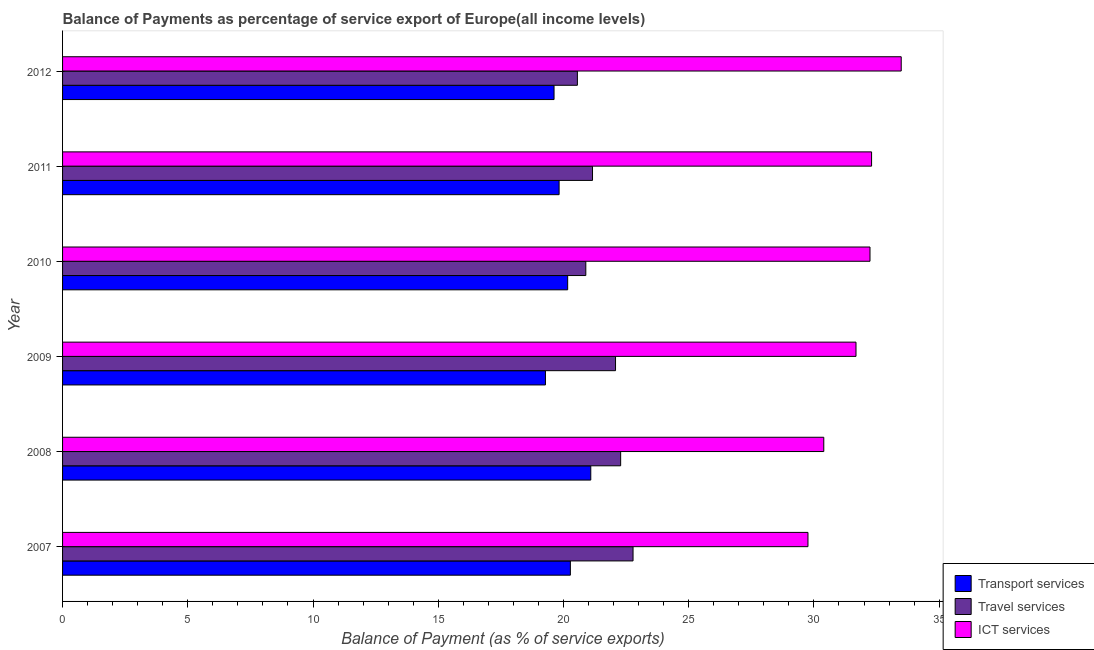How many groups of bars are there?
Your answer should be compact. 6. Are the number of bars per tick equal to the number of legend labels?
Provide a succinct answer. Yes. How many bars are there on the 4th tick from the bottom?
Offer a very short reply. 3. In how many cases, is the number of bars for a given year not equal to the number of legend labels?
Provide a succinct answer. 0. What is the balance of payment of ict services in 2007?
Keep it short and to the point. 29.76. Across all years, what is the maximum balance of payment of travel services?
Make the answer very short. 22.78. Across all years, what is the minimum balance of payment of transport services?
Offer a terse response. 19.28. In which year was the balance of payment of ict services minimum?
Your answer should be very brief. 2007. What is the total balance of payment of transport services in the graph?
Ensure brevity in your answer.  120.27. What is the difference between the balance of payment of transport services in 2008 and that in 2012?
Your answer should be very brief. 1.47. What is the difference between the balance of payment of travel services in 2009 and the balance of payment of ict services in 2008?
Your answer should be compact. -8.31. What is the average balance of payment of ict services per year?
Ensure brevity in your answer.  31.64. In the year 2012, what is the difference between the balance of payment of travel services and balance of payment of transport services?
Your answer should be very brief. 0.93. In how many years, is the balance of payment of ict services greater than 25 %?
Your answer should be very brief. 6. What is the ratio of the balance of payment of transport services in 2009 to that in 2012?
Your answer should be compact. 0.98. Is the balance of payment of travel services in 2008 less than that in 2011?
Make the answer very short. No. What is the difference between the highest and the second highest balance of payment of transport services?
Provide a short and direct response. 0.81. What is the difference between the highest and the lowest balance of payment of ict services?
Your answer should be compact. 3.72. In how many years, is the balance of payment of travel services greater than the average balance of payment of travel services taken over all years?
Ensure brevity in your answer.  3. What does the 2nd bar from the top in 2011 represents?
Keep it short and to the point. Travel services. What does the 1st bar from the bottom in 2007 represents?
Your response must be concise. Transport services. Is it the case that in every year, the sum of the balance of payment of transport services and balance of payment of travel services is greater than the balance of payment of ict services?
Provide a short and direct response. Yes. Are all the bars in the graph horizontal?
Keep it short and to the point. Yes. How many years are there in the graph?
Offer a very short reply. 6. What is the difference between two consecutive major ticks on the X-axis?
Give a very brief answer. 5. Are the values on the major ticks of X-axis written in scientific E-notation?
Keep it short and to the point. No. Does the graph contain grids?
Provide a succinct answer. No. Where does the legend appear in the graph?
Make the answer very short. Bottom right. How many legend labels are there?
Provide a short and direct response. 3. How are the legend labels stacked?
Your response must be concise. Vertical. What is the title of the graph?
Offer a very short reply. Balance of Payments as percentage of service export of Europe(all income levels). Does "Slovak Republic" appear as one of the legend labels in the graph?
Ensure brevity in your answer.  No. What is the label or title of the X-axis?
Offer a terse response. Balance of Payment (as % of service exports). What is the label or title of the Y-axis?
Ensure brevity in your answer.  Year. What is the Balance of Payment (as % of service exports) in Transport services in 2007?
Give a very brief answer. 20.28. What is the Balance of Payment (as % of service exports) of Travel services in 2007?
Offer a terse response. 22.78. What is the Balance of Payment (as % of service exports) of ICT services in 2007?
Make the answer very short. 29.76. What is the Balance of Payment (as % of service exports) of Transport services in 2008?
Your response must be concise. 21.09. What is the Balance of Payment (as % of service exports) of Travel services in 2008?
Offer a very short reply. 22.28. What is the Balance of Payment (as % of service exports) of ICT services in 2008?
Give a very brief answer. 30.39. What is the Balance of Payment (as % of service exports) in Transport services in 2009?
Provide a succinct answer. 19.28. What is the Balance of Payment (as % of service exports) of Travel services in 2009?
Keep it short and to the point. 22.08. What is the Balance of Payment (as % of service exports) of ICT services in 2009?
Offer a very short reply. 31.68. What is the Balance of Payment (as % of service exports) in Transport services in 2010?
Keep it short and to the point. 20.17. What is the Balance of Payment (as % of service exports) in Travel services in 2010?
Offer a very short reply. 20.89. What is the Balance of Payment (as % of service exports) of ICT services in 2010?
Offer a very short reply. 32.24. What is the Balance of Payment (as % of service exports) of Transport services in 2011?
Make the answer very short. 19.83. What is the Balance of Payment (as % of service exports) in Travel services in 2011?
Your response must be concise. 21.16. What is the Balance of Payment (as % of service exports) of ICT services in 2011?
Offer a very short reply. 32.3. What is the Balance of Payment (as % of service exports) of Transport services in 2012?
Your answer should be very brief. 19.62. What is the Balance of Payment (as % of service exports) in Travel services in 2012?
Make the answer very short. 20.56. What is the Balance of Payment (as % of service exports) of ICT services in 2012?
Offer a terse response. 33.49. Across all years, what is the maximum Balance of Payment (as % of service exports) in Transport services?
Your answer should be very brief. 21.09. Across all years, what is the maximum Balance of Payment (as % of service exports) of Travel services?
Offer a very short reply. 22.78. Across all years, what is the maximum Balance of Payment (as % of service exports) in ICT services?
Provide a succinct answer. 33.49. Across all years, what is the minimum Balance of Payment (as % of service exports) of Transport services?
Make the answer very short. 19.28. Across all years, what is the minimum Balance of Payment (as % of service exports) of Travel services?
Keep it short and to the point. 20.56. Across all years, what is the minimum Balance of Payment (as % of service exports) of ICT services?
Give a very brief answer. 29.76. What is the total Balance of Payment (as % of service exports) of Transport services in the graph?
Your answer should be compact. 120.27. What is the total Balance of Payment (as % of service exports) of Travel services in the graph?
Provide a short and direct response. 129.75. What is the total Balance of Payment (as % of service exports) of ICT services in the graph?
Give a very brief answer. 189.86. What is the difference between the Balance of Payment (as % of service exports) in Transport services in 2007 and that in 2008?
Your response must be concise. -0.82. What is the difference between the Balance of Payment (as % of service exports) of Travel services in 2007 and that in 2008?
Provide a succinct answer. 0.49. What is the difference between the Balance of Payment (as % of service exports) of ICT services in 2007 and that in 2008?
Offer a very short reply. -0.63. What is the difference between the Balance of Payment (as % of service exports) in Transport services in 2007 and that in 2009?
Give a very brief answer. 0.99. What is the difference between the Balance of Payment (as % of service exports) of Travel services in 2007 and that in 2009?
Your answer should be compact. 0.7. What is the difference between the Balance of Payment (as % of service exports) of ICT services in 2007 and that in 2009?
Your answer should be very brief. -1.92. What is the difference between the Balance of Payment (as % of service exports) in Transport services in 2007 and that in 2010?
Your answer should be very brief. 0.11. What is the difference between the Balance of Payment (as % of service exports) in Travel services in 2007 and that in 2010?
Ensure brevity in your answer.  1.89. What is the difference between the Balance of Payment (as % of service exports) in ICT services in 2007 and that in 2010?
Ensure brevity in your answer.  -2.48. What is the difference between the Balance of Payment (as % of service exports) in Transport services in 2007 and that in 2011?
Offer a terse response. 0.45. What is the difference between the Balance of Payment (as % of service exports) in Travel services in 2007 and that in 2011?
Provide a short and direct response. 1.62. What is the difference between the Balance of Payment (as % of service exports) in ICT services in 2007 and that in 2011?
Offer a very short reply. -2.54. What is the difference between the Balance of Payment (as % of service exports) of Transport services in 2007 and that in 2012?
Offer a very short reply. 0.65. What is the difference between the Balance of Payment (as % of service exports) of Travel services in 2007 and that in 2012?
Your response must be concise. 2.22. What is the difference between the Balance of Payment (as % of service exports) of ICT services in 2007 and that in 2012?
Provide a short and direct response. -3.72. What is the difference between the Balance of Payment (as % of service exports) in Transport services in 2008 and that in 2009?
Give a very brief answer. 1.81. What is the difference between the Balance of Payment (as % of service exports) of Travel services in 2008 and that in 2009?
Offer a very short reply. 0.2. What is the difference between the Balance of Payment (as % of service exports) in ICT services in 2008 and that in 2009?
Your answer should be very brief. -1.29. What is the difference between the Balance of Payment (as % of service exports) in Travel services in 2008 and that in 2010?
Make the answer very short. 1.39. What is the difference between the Balance of Payment (as % of service exports) of ICT services in 2008 and that in 2010?
Your answer should be very brief. -1.85. What is the difference between the Balance of Payment (as % of service exports) in Transport services in 2008 and that in 2011?
Offer a very short reply. 1.26. What is the difference between the Balance of Payment (as % of service exports) of Travel services in 2008 and that in 2011?
Give a very brief answer. 1.12. What is the difference between the Balance of Payment (as % of service exports) of ICT services in 2008 and that in 2011?
Your answer should be compact. -1.91. What is the difference between the Balance of Payment (as % of service exports) of Transport services in 2008 and that in 2012?
Give a very brief answer. 1.47. What is the difference between the Balance of Payment (as % of service exports) of Travel services in 2008 and that in 2012?
Give a very brief answer. 1.73. What is the difference between the Balance of Payment (as % of service exports) of ICT services in 2008 and that in 2012?
Your response must be concise. -3.09. What is the difference between the Balance of Payment (as % of service exports) of Transport services in 2009 and that in 2010?
Make the answer very short. -0.89. What is the difference between the Balance of Payment (as % of service exports) in Travel services in 2009 and that in 2010?
Provide a succinct answer. 1.19. What is the difference between the Balance of Payment (as % of service exports) in ICT services in 2009 and that in 2010?
Provide a short and direct response. -0.56. What is the difference between the Balance of Payment (as % of service exports) in Transport services in 2009 and that in 2011?
Offer a very short reply. -0.55. What is the difference between the Balance of Payment (as % of service exports) in Travel services in 2009 and that in 2011?
Give a very brief answer. 0.92. What is the difference between the Balance of Payment (as % of service exports) of ICT services in 2009 and that in 2011?
Keep it short and to the point. -0.62. What is the difference between the Balance of Payment (as % of service exports) of Transport services in 2009 and that in 2012?
Provide a succinct answer. -0.34. What is the difference between the Balance of Payment (as % of service exports) of Travel services in 2009 and that in 2012?
Ensure brevity in your answer.  1.52. What is the difference between the Balance of Payment (as % of service exports) of ICT services in 2009 and that in 2012?
Keep it short and to the point. -1.81. What is the difference between the Balance of Payment (as % of service exports) in Transport services in 2010 and that in 2011?
Ensure brevity in your answer.  0.34. What is the difference between the Balance of Payment (as % of service exports) in Travel services in 2010 and that in 2011?
Your answer should be compact. -0.27. What is the difference between the Balance of Payment (as % of service exports) in ICT services in 2010 and that in 2011?
Give a very brief answer. -0.06. What is the difference between the Balance of Payment (as % of service exports) in Transport services in 2010 and that in 2012?
Provide a short and direct response. 0.54. What is the difference between the Balance of Payment (as % of service exports) of Travel services in 2010 and that in 2012?
Offer a very short reply. 0.34. What is the difference between the Balance of Payment (as % of service exports) of ICT services in 2010 and that in 2012?
Offer a terse response. -1.25. What is the difference between the Balance of Payment (as % of service exports) in Transport services in 2011 and that in 2012?
Make the answer very short. 0.2. What is the difference between the Balance of Payment (as % of service exports) in Travel services in 2011 and that in 2012?
Your response must be concise. 0.6. What is the difference between the Balance of Payment (as % of service exports) in ICT services in 2011 and that in 2012?
Keep it short and to the point. -1.18. What is the difference between the Balance of Payment (as % of service exports) of Transport services in 2007 and the Balance of Payment (as % of service exports) of Travel services in 2008?
Your answer should be very brief. -2.01. What is the difference between the Balance of Payment (as % of service exports) of Transport services in 2007 and the Balance of Payment (as % of service exports) of ICT services in 2008?
Ensure brevity in your answer.  -10.12. What is the difference between the Balance of Payment (as % of service exports) of Travel services in 2007 and the Balance of Payment (as % of service exports) of ICT services in 2008?
Your response must be concise. -7.62. What is the difference between the Balance of Payment (as % of service exports) of Transport services in 2007 and the Balance of Payment (as % of service exports) of Travel services in 2009?
Your answer should be very brief. -1.8. What is the difference between the Balance of Payment (as % of service exports) in Transport services in 2007 and the Balance of Payment (as % of service exports) in ICT services in 2009?
Offer a very short reply. -11.4. What is the difference between the Balance of Payment (as % of service exports) in Travel services in 2007 and the Balance of Payment (as % of service exports) in ICT services in 2009?
Your response must be concise. -8.9. What is the difference between the Balance of Payment (as % of service exports) in Transport services in 2007 and the Balance of Payment (as % of service exports) in Travel services in 2010?
Give a very brief answer. -0.62. What is the difference between the Balance of Payment (as % of service exports) in Transport services in 2007 and the Balance of Payment (as % of service exports) in ICT services in 2010?
Your response must be concise. -11.96. What is the difference between the Balance of Payment (as % of service exports) in Travel services in 2007 and the Balance of Payment (as % of service exports) in ICT services in 2010?
Your answer should be compact. -9.46. What is the difference between the Balance of Payment (as % of service exports) of Transport services in 2007 and the Balance of Payment (as % of service exports) of Travel services in 2011?
Provide a succinct answer. -0.88. What is the difference between the Balance of Payment (as % of service exports) in Transport services in 2007 and the Balance of Payment (as % of service exports) in ICT services in 2011?
Your answer should be compact. -12.03. What is the difference between the Balance of Payment (as % of service exports) of Travel services in 2007 and the Balance of Payment (as % of service exports) of ICT services in 2011?
Offer a very short reply. -9.52. What is the difference between the Balance of Payment (as % of service exports) of Transport services in 2007 and the Balance of Payment (as % of service exports) of Travel services in 2012?
Your response must be concise. -0.28. What is the difference between the Balance of Payment (as % of service exports) of Transport services in 2007 and the Balance of Payment (as % of service exports) of ICT services in 2012?
Ensure brevity in your answer.  -13.21. What is the difference between the Balance of Payment (as % of service exports) of Travel services in 2007 and the Balance of Payment (as % of service exports) of ICT services in 2012?
Your response must be concise. -10.71. What is the difference between the Balance of Payment (as % of service exports) of Transport services in 2008 and the Balance of Payment (as % of service exports) of Travel services in 2009?
Ensure brevity in your answer.  -0.99. What is the difference between the Balance of Payment (as % of service exports) of Transport services in 2008 and the Balance of Payment (as % of service exports) of ICT services in 2009?
Your answer should be compact. -10.59. What is the difference between the Balance of Payment (as % of service exports) of Travel services in 2008 and the Balance of Payment (as % of service exports) of ICT services in 2009?
Your answer should be compact. -9.4. What is the difference between the Balance of Payment (as % of service exports) in Transport services in 2008 and the Balance of Payment (as % of service exports) in Travel services in 2010?
Your response must be concise. 0.2. What is the difference between the Balance of Payment (as % of service exports) in Transport services in 2008 and the Balance of Payment (as % of service exports) in ICT services in 2010?
Your response must be concise. -11.15. What is the difference between the Balance of Payment (as % of service exports) of Travel services in 2008 and the Balance of Payment (as % of service exports) of ICT services in 2010?
Ensure brevity in your answer.  -9.96. What is the difference between the Balance of Payment (as % of service exports) of Transport services in 2008 and the Balance of Payment (as % of service exports) of Travel services in 2011?
Provide a succinct answer. -0.07. What is the difference between the Balance of Payment (as % of service exports) in Transport services in 2008 and the Balance of Payment (as % of service exports) in ICT services in 2011?
Keep it short and to the point. -11.21. What is the difference between the Balance of Payment (as % of service exports) in Travel services in 2008 and the Balance of Payment (as % of service exports) in ICT services in 2011?
Offer a terse response. -10.02. What is the difference between the Balance of Payment (as % of service exports) in Transport services in 2008 and the Balance of Payment (as % of service exports) in Travel services in 2012?
Give a very brief answer. 0.53. What is the difference between the Balance of Payment (as % of service exports) of Transport services in 2008 and the Balance of Payment (as % of service exports) of ICT services in 2012?
Provide a succinct answer. -12.39. What is the difference between the Balance of Payment (as % of service exports) of Travel services in 2008 and the Balance of Payment (as % of service exports) of ICT services in 2012?
Keep it short and to the point. -11.2. What is the difference between the Balance of Payment (as % of service exports) of Transport services in 2009 and the Balance of Payment (as % of service exports) of Travel services in 2010?
Give a very brief answer. -1.61. What is the difference between the Balance of Payment (as % of service exports) in Transport services in 2009 and the Balance of Payment (as % of service exports) in ICT services in 2010?
Make the answer very short. -12.96. What is the difference between the Balance of Payment (as % of service exports) in Travel services in 2009 and the Balance of Payment (as % of service exports) in ICT services in 2010?
Keep it short and to the point. -10.16. What is the difference between the Balance of Payment (as % of service exports) of Transport services in 2009 and the Balance of Payment (as % of service exports) of Travel services in 2011?
Ensure brevity in your answer.  -1.88. What is the difference between the Balance of Payment (as % of service exports) of Transport services in 2009 and the Balance of Payment (as % of service exports) of ICT services in 2011?
Ensure brevity in your answer.  -13.02. What is the difference between the Balance of Payment (as % of service exports) of Travel services in 2009 and the Balance of Payment (as % of service exports) of ICT services in 2011?
Offer a very short reply. -10.22. What is the difference between the Balance of Payment (as % of service exports) in Transport services in 2009 and the Balance of Payment (as % of service exports) in Travel services in 2012?
Provide a short and direct response. -1.28. What is the difference between the Balance of Payment (as % of service exports) of Transport services in 2009 and the Balance of Payment (as % of service exports) of ICT services in 2012?
Give a very brief answer. -14.21. What is the difference between the Balance of Payment (as % of service exports) of Travel services in 2009 and the Balance of Payment (as % of service exports) of ICT services in 2012?
Your answer should be very brief. -11.41. What is the difference between the Balance of Payment (as % of service exports) of Transport services in 2010 and the Balance of Payment (as % of service exports) of Travel services in 2011?
Offer a terse response. -0.99. What is the difference between the Balance of Payment (as % of service exports) in Transport services in 2010 and the Balance of Payment (as % of service exports) in ICT services in 2011?
Make the answer very short. -12.13. What is the difference between the Balance of Payment (as % of service exports) of Travel services in 2010 and the Balance of Payment (as % of service exports) of ICT services in 2011?
Your answer should be very brief. -11.41. What is the difference between the Balance of Payment (as % of service exports) of Transport services in 2010 and the Balance of Payment (as % of service exports) of Travel services in 2012?
Your answer should be compact. -0.39. What is the difference between the Balance of Payment (as % of service exports) of Transport services in 2010 and the Balance of Payment (as % of service exports) of ICT services in 2012?
Your answer should be very brief. -13.32. What is the difference between the Balance of Payment (as % of service exports) of Travel services in 2010 and the Balance of Payment (as % of service exports) of ICT services in 2012?
Your answer should be very brief. -12.59. What is the difference between the Balance of Payment (as % of service exports) of Transport services in 2011 and the Balance of Payment (as % of service exports) of Travel services in 2012?
Keep it short and to the point. -0.73. What is the difference between the Balance of Payment (as % of service exports) in Transport services in 2011 and the Balance of Payment (as % of service exports) in ICT services in 2012?
Your answer should be compact. -13.66. What is the difference between the Balance of Payment (as % of service exports) in Travel services in 2011 and the Balance of Payment (as % of service exports) in ICT services in 2012?
Your response must be concise. -12.33. What is the average Balance of Payment (as % of service exports) in Transport services per year?
Your answer should be compact. 20.04. What is the average Balance of Payment (as % of service exports) in Travel services per year?
Your answer should be very brief. 21.62. What is the average Balance of Payment (as % of service exports) in ICT services per year?
Give a very brief answer. 31.64. In the year 2007, what is the difference between the Balance of Payment (as % of service exports) in Transport services and Balance of Payment (as % of service exports) in Travel services?
Keep it short and to the point. -2.5. In the year 2007, what is the difference between the Balance of Payment (as % of service exports) in Transport services and Balance of Payment (as % of service exports) in ICT services?
Ensure brevity in your answer.  -9.49. In the year 2007, what is the difference between the Balance of Payment (as % of service exports) in Travel services and Balance of Payment (as % of service exports) in ICT services?
Provide a succinct answer. -6.98. In the year 2008, what is the difference between the Balance of Payment (as % of service exports) in Transport services and Balance of Payment (as % of service exports) in Travel services?
Your response must be concise. -1.19. In the year 2008, what is the difference between the Balance of Payment (as % of service exports) of Transport services and Balance of Payment (as % of service exports) of ICT services?
Keep it short and to the point. -9.3. In the year 2008, what is the difference between the Balance of Payment (as % of service exports) of Travel services and Balance of Payment (as % of service exports) of ICT services?
Your answer should be very brief. -8.11. In the year 2009, what is the difference between the Balance of Payment (as % of service exports) in Transport services and Balance of Payment (as % of service exports) in Travel services?
Keep it short and to the point. -2.8. In the year 2009, what is the difference between the Balance of Payment (as % of service exports) of Transport services and Balance of Payment (as % of service exports) of ICT services?
Ensure brevity in your answer.  -12.4. In the year 2009, what is the difference between the Balance of Payment (as % of service exports) in Travel services and Balance of Payment (as % of service exports) in ICT services?
Your answer should be compact. -9.6. In the year 2010, what is the difference between the Balance of Payment (as % of service exports) of Transport services and Balance of Payment (as % of service exports) of Travel services?
Give a very brief answer. -0.72. In the year 2010, what is the difference between the Balance of Payment (as % of service exports) of Transport services and Balance of Payment (as % of service exports) of ICT services?
Give a very brief answer. -12.07. In the year 2010, what is the difference between the Balance of Payment (as % of service exports) of Travel services and Balance of Payment (as % of service exports) of ICT services?
Your answer should be compact. -11.35. In the year 2011, what is the difference between the Balance of Payment (as % of service exports) in Transport services and Balance of Payment (as % of service exports) in Travel services?
Provide a short and direct response. -1.33. In the year 2011, what is the difference between the Balance of Payment (as % of service exports) in Transport services and Balance of Payment (as % of service exports) in ICT services?
Your answer should be compact. -12.48. In the year 2011, what is the difference between the Balance of Payment (as % of service exports) of Travel services and Balance of Payment (as % of service exports) of ICT services?
Ensure brevity in your answer.  -11.14. In the year 2012, what is the difference between the Balance of Payment (as % of service exports) of Transport services and Balance of Payment (as % of service exports) of Travel services?
Give a very brief answer. -0.93. In the year 2012, what is the difference between the Balance of Payment (as % of service exports) in Transport services and Balance of Payment (as % of service exports) in ICT services?
Make the answer very short. -13.86. In the year 2012, what is the difference between the Balance of Payment (as % of service exports) of Travel services and Balance of Payment (as % of service exports) of ICT services?
Make the answer very short. -12.93. What is the ratio of the Balance of Payment (as % of service exports) in Transport services in 2007 to that in 2008?
Keep it short and to the point. 0.96. What is the ratio of the Balance of Payment (as % of service exports) of Travel services in 2007 to that in 2008?
Offer a very short reply. 1.02. What is the ratio of the Balance of Payment (as % of service exports) in ICT services in 2007 to that in 2008?
Your response must be concise. 0.98. What is the ratio of the Balance of Payment (as % of service exports) of Transport services in 2007 to that in 2009?
Ensure brevity in your answer.  1.05. What is the ratio of the Balance of Payment (as % of service exports) of Travel services in 2007 to that in 2009?
Make the answer very short. 1.03. What is the ratio of the Balance of Payment (as % of service exports) in ICT services in 2007 to that in 2009?
Keep it short and to the point. 0.94. What is the ratio of the Balance of Payment (as % of service exports) in Transport services in 2007 to that in 2010?
Your answer should be very brief. 1.01. What is the ratio of the Balance of Payment (as % of service exports) in Travel services in 2007 to that in 2010?
Your response must be concise. 1.09. What is the ratio of the Balance of Payment (as % of service exports) in ICT services in 2007 to that in 2010?
Make the answer very short. 0.92. What is the ratio of the Balance of Payment (as % of service exports) of Transport services in 2007 to that in 2011?
Keep it short and to the point. 1.02. What is the ratio of the Balance of Payment (as % of service exports) of Travel services in 2007 to that in 2011?
Your response must be concise. 1.08. What is the ratio of the Balance of Payment (as % of service exports) in ICT services in 2007 to that in 2011?
Keep it short and to the point. 0.92. What is the ratio of the Balance of Payment (as % of service exports) of Transport services in 2007 to that in 2012?
Offer a terse response. 1.03. What is the ratio of the Balance of Payment (as % of service exports) in Travel services in 2007 to that in 2012?
Make the answer very short. 1.11. What is the ratio of the Balance of Payment (as % of service exports) in ICT services in 2007 to that in 2012?
Make the answer very short. 0.89. What is the ratio of the Balance of Payment (as % of service exports) in Transport services in 2008 to that in 2009?
Your answer should be very brief. 1.09. What is the ratio of the Balance of Payment (as % of service exports) in Travel services in 2008 to that in 2009?
Ensure brevity in your answer.  1.01. What is the ratio of the Balance of Payment (as % of service exports) of ICT services in 2008 to that in 2009?
Your response must be concise. 0.96. What is the ratio of the Balance of Payment (as % of service exports) of Transport services in 2008 to that in 2010?
Give a very brief answer. 1.05. What is the ratio of the Balance of Payment (as % of service exports) in Travel services in 2008 to that in 2010?
Your response must be concise. 1.07. What is the ratio of the Balance of Payment (as % of service exports) of ICT services in 2008 to that in 2010?
Provide a short and direct response. 0.94. What is the ratio of the Balance of Payment (as % of service exports) of Transport services in 2008 to that in 2011?
Give a very brief answer. 1.06. What is the ratio of the Balance of Payment (as % of service exports) of Travel services in 2008 to that in 2011?
Your answer should be compact. 1.05. What is the ratio of the Balance of Payment (as % of service exports) in ICT services in 2008 to that in 2011?
Offer a terse response. 0.94. What is the ratio of the Balance of Payment (as % of service exports) in Transport services in 2008 to that in 2012?
Your response must be concise. 1.07. What is the ratio of the Balance of Payment (as % of service exports) in Travel services in 2008 to that in 2012?
Your answer should be very brief. 1.08. What is the ratio of the Balance of Payment (as % of service exports) of ICT services in 2008 to that in 2012?
Ensure brevity in your answer.  0.91. What is the ratio of the Balance of Payment (as % of service exports) in Transport services in 2009 to that in 2010?
Your answer should be compact. 0.96. What is the ratio of the Balance of Payment (as % of service exports) in Travel services in 2009 to that in 2010?
Your answer should be compact. 1.06. What is the ratio of the Balance of Payment (as % of service exports) in ICT services in 2009 to that in 2010?
Provide a succinct answer. 0.98. What is the ratio of the Balance of Payment (as % of service exports) of Transport services in 2009 to that in 2011?
Provide a succinct answer. 0.97. What is the ratio of the Balance of Payment (as % of service exports) of Travel services in 2009 to that in 2011?
Offer a terse response. 1.04. What is the ratio of the Balance of Payment (as % of service exports) of ICT services in 2009 to that in 2011?
Your answer should be very brief. 0.98. What is the ratio of the Balance of Payment (as % of service exports) of Transport services in 2009 to that in 2012?
Your response must be concise. 0.98. What is the ratio of the Balance of Payment (as % of service exports) in Travel services in 2009 to that in 2012?
Offer a terse response. 1.07. What is the ratio of the Balance of Payment (as % of service exports) in ICT services in 2009 to that in 2012?
Your answer should be very brief. 0.95. What is the ratio of the Balance of Payment (as % of service exports) of Transport services in 2010 to that in 2011?
Provide a succinct answer. 1.02. What is the ratio of the Balance of Payment (as % of service exports) of Travel services in 2010 to that in 2011?
Keep it short and to the point. 0.99. What is the ratio of the Balance of Payment (as % of service exports) of Transport services in 2010 to that in 2012?
Ensure brevity in your answer.  1.03. What is the ratio of the Balance of Payment (as % of service exports) in Travel services in 2010 to that in 2012?
Provide a succinct answer. 1.02. What is the ratio of the Balance of Payment (as % of service exports) of ICT services in 2010 to that in 2012?
Ensure brevity in your answer.  0.96. What is the ratio of the Balance of Payment (as % of service exports) in Transport services in 2011 to that in 2012?
Your response must be concise. 1.01. What is the ratio of the Balance of Payment (as % of service exports) of Travel services in 2011 to that in 2012?
Provide a short and direct response. 1.03. What is the ratio of the Balance of Payment (as % of service exports) of ICT services in 2011 to that in 2012?
Your answer should be compact. 0.96. What is the difference between the highest and the second highest Balance of Payment (as % of service exports) in Transport services?
Offer a terse response. 0.82. What is the difference between the highest and the second highest Balance of Payment (as % of service exports) in Travel services?
Provide a succinct answer. 0.49. What is the difference between the highest and the second highest Balance of Payment (as % of service exports) in ICT services?
Keep it short and to the point. 1.18. What is the difference between the highest and the lowest Balance of Payment (as % of service exports) in Transport services?
Your answer should be compact. 1.81. What is the difference between the highest and the lowest Balance of Payment (as % of service exports) of Travel services?
Keep it short and to the point. 2.22. What is the difference between the highest and the lowest Balance of Payment (as % of service exports) of ICT services?
Your response must be concise. 3.72. 